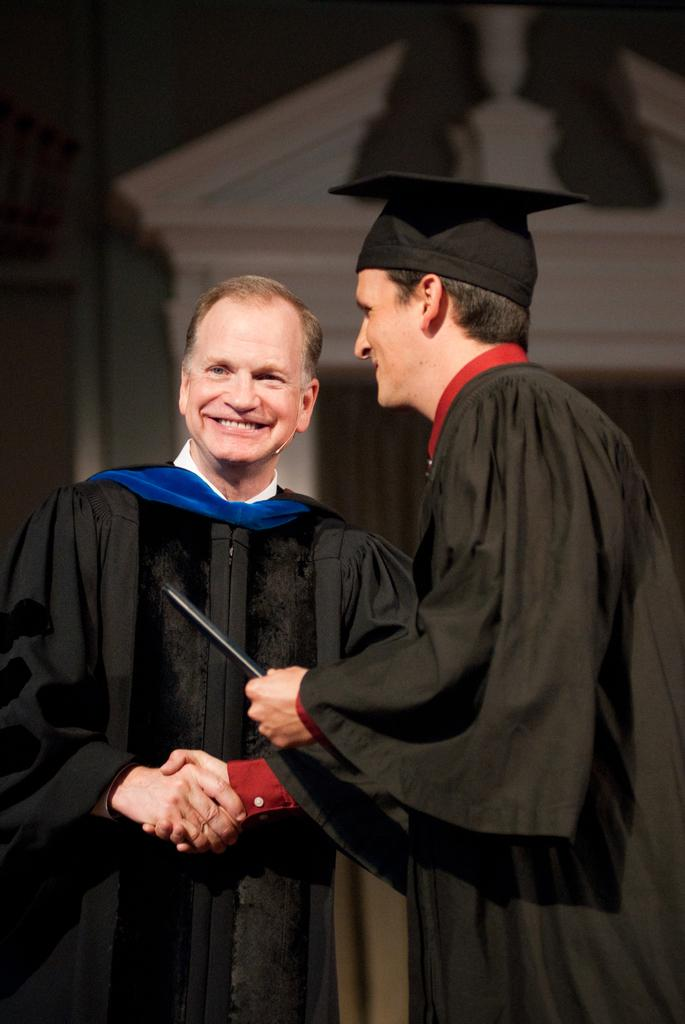How many people are in the image? There are two men in the image. What are the men doing in the image? The men are standing and shaking hands. What are the men wearing in the image? The men are wearing convocation dress. Can you see any kitties or frogs in the image? No, there are no kitties or frogs present in the image. What type of reward is the man on the left receiving in the image? There is no reward visible in the image; the men are simply shaking hands. 